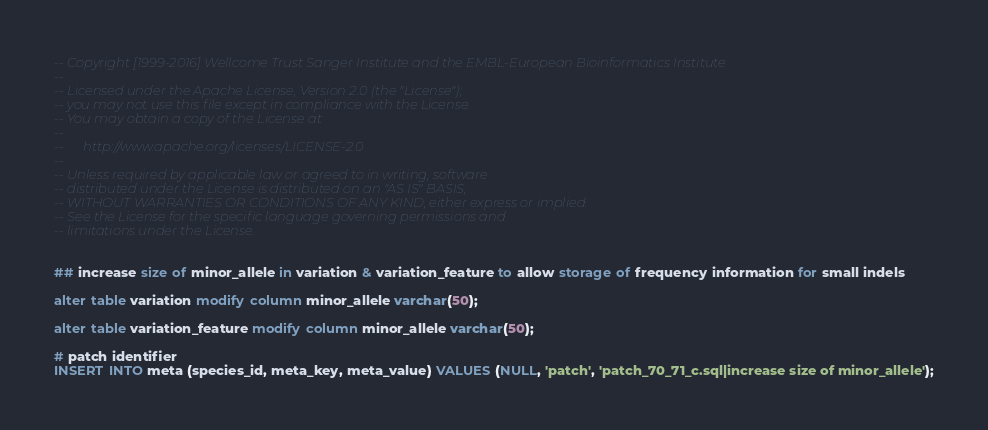Convert code to text. <code><loc_0><loc_0><loc_500><loc_500><_SQL_>-- Copyright [1999-2016] Wellcome Trust Sanger Institute and the EMBL-European Bioinformatics Institute
-- 
-- Licensed under the Apache License, Version 2.0 (the "License");
-- you may not use this file except in compliance with the License.
-- You may obtain a copy of the License at
-- 
--      http://www.apache.org/licenses/LICENSE-2.0
-- 
-- Unless required by applicable law or agreed to in writing, software
-- distributed under the License is distributed on an "AS IS" BASIS,
-- WITHOUT WARRANTIES OR CONDITIONS OF ANY KIND, either express or implied.
-- See the License for the specific language governing permissions and
-- limitations under the License.


## increase size of minor_allele in variation & variation_feature to allow storage of frequency information for small indels

alter table variation modify column minor_allele varchar(50);

alter table variation_feature modify column minor_allele varchar(50);

# patch identifier
INSERT INTO meta (species_id, meta_key, meta_value) VALUES (NULL, 'patch', 'patch_70_71_c.sql|increase size of minor_allele');
</code> 